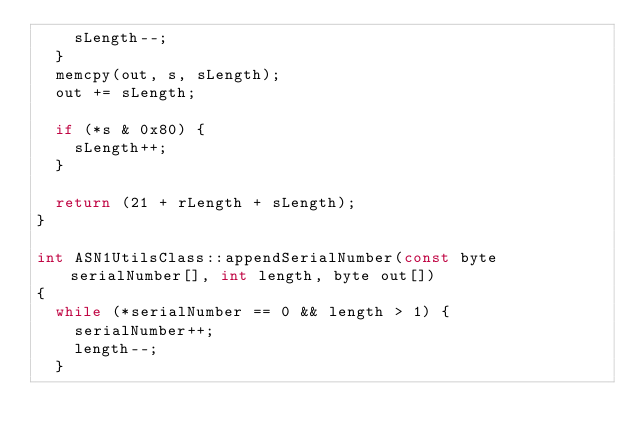Convert code to text. <code><loc_0><loc_0><loc_500><loc_500><_C++_>    sLength--;
  }
  memcpy(out, s, sLength);
  out += sLength;
  
  if (*s & 0x80) {
    sLength++;
  }
  
  return (21 + rLength + sLength);
}

int ASN1UtilsClass::appendSerialNumber(const byte serialNumber[], int length, byte out[])
{
  while (*serialNumber == 0 && length > 1) {
    serialNumber++;
    length--;
  }
</code> 